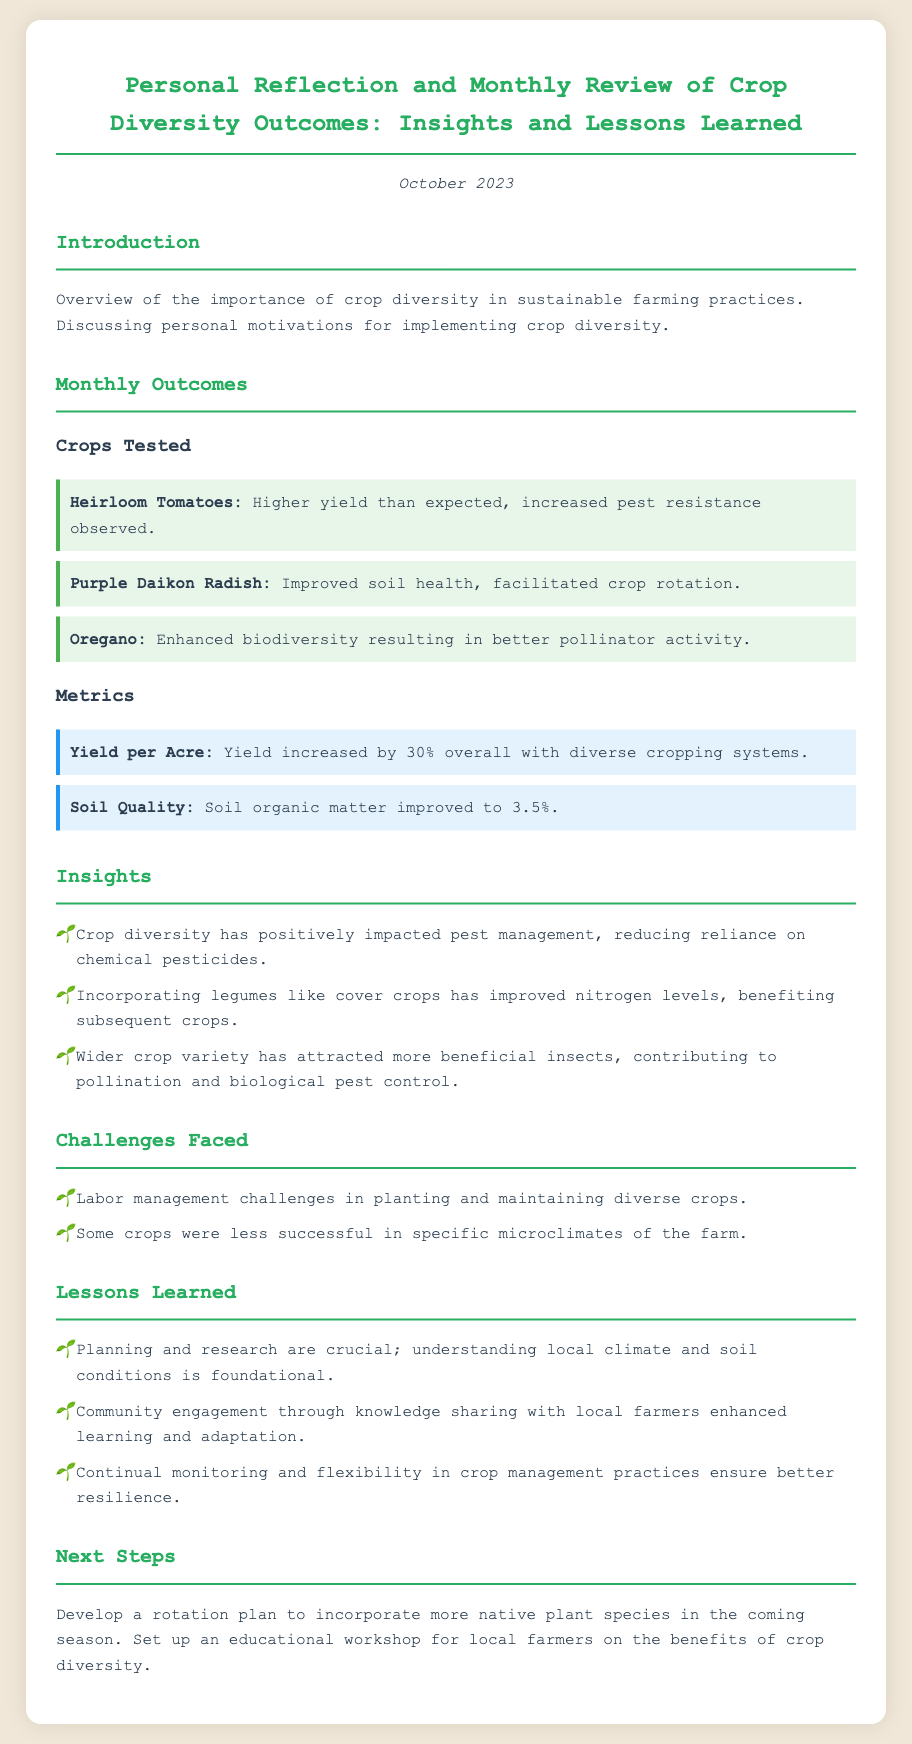what month is being reviewed? The document reviews the outcomes for the month of October 2023.
Answer: October 2023 which crop showed improved soil health? The Purple Daikon Radish was noted for improved soil health in the document.
Answer: Purple Daikon Radish what percentage did the yield increase overall? The overall yield increase was stated as 30% in the metrics section.
Answer: 30% what is the improved soil organic matter percentage? The document specifies the improved soil organic matter as 3.5%.
Answer: 3.5% what challenge was faced regarding crop management? One challenge mentioned was labor management in planting and maintaining diverse crops.
Answer: Labor management how did crop diversity affect pest management? The document notes that crop diversity positively impacted pest management by reducing reliance on chemical pesticides.
Answer: Reduced reliance on chemical pesticides what is one lesson learned from diversity implementation? A crucial lesson learned was that planning and research are foundational for understanding local climate and soil conditions.
Answer: Planning and research what next step involves local farmers? The next step includes setting up an educational workshop for local farmers.
Answer: Educational workshop which crop was mentioned as enhancing biodiversity and pollinator activity? Oregano was highlighted in the document for enhancing biodiversity and better pollinator activity.
Answer: Oregano 